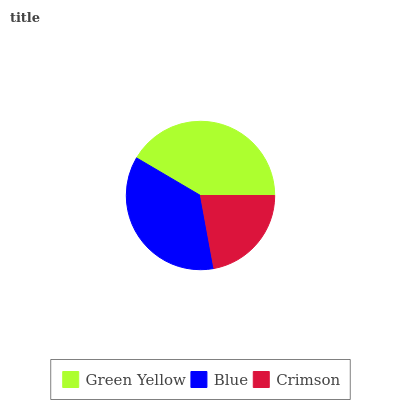Is Crimson the minimum?
Answer yes or no. Yes. Is Green Yellow the maximum?
Answer yes or no. Yes. Is Blue the minimum?
Answer yes or no. No. Is Blue the maximum?
Answer yes or no. No. Is Green Yellow greater than Blue?
Answer yes or no. Yes. Is Blue less than Green Yellow?
Answer yes or no. Yes. Is Blue greater than Green Yellow?
Answer yes or no. No. Is Green Yellow less than Blue?
Answer yes or no. No. Is Blue the high median?
Answer yes or no. Yes. Is Blue the low median?
Answer yes or no. Yes. Is Green Yellow the high median?
Answer yes or no. No. Is Crimson the low median?
Answer yes or no. No. 